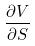Convert formula to latex. <formula><loc_0><loc_0><loc_500><loc_500>\frac { \partial V } { \partial S }</formula> 